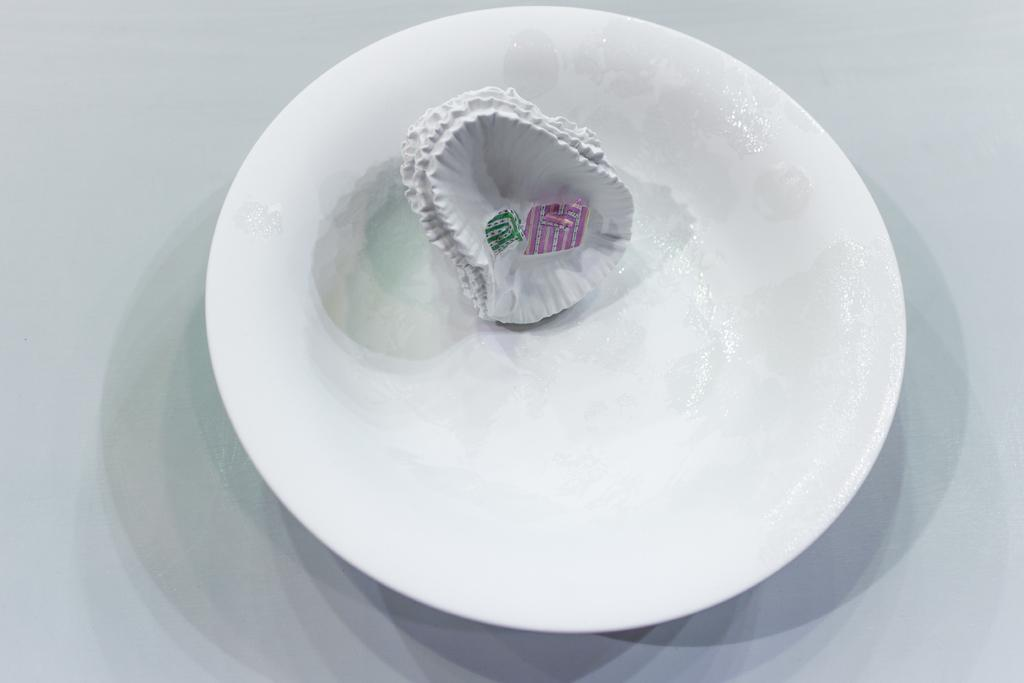What is placed on the plate in the image? There are covers on a plate. What is the color of the plate? The plate is white in color. What type of pollution can be seen in the image? There is no pollution present in the image; it only features a plate with covers on it. How many fingers are visible in the image? There are no fingers visible in the image. 